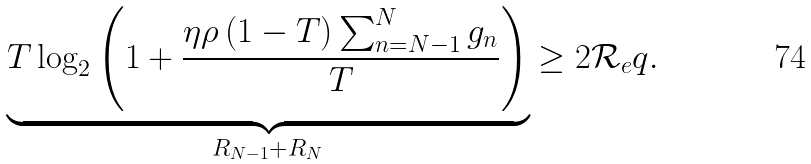<formula> <loc_0><loc_0><loc_500><loc_500>\underbrace { T \log _ { 2 } \left ( 1 + \frac { \eta \rho \left ( 1 - T \right ) \sum _ { n = N - 1 } ^ { N } g _ { n } } { T } \right ) } _ { R _ { N - 1 } + R _ { N } } \geq 2 \mathcal { R } _ { e } q .</formula> 